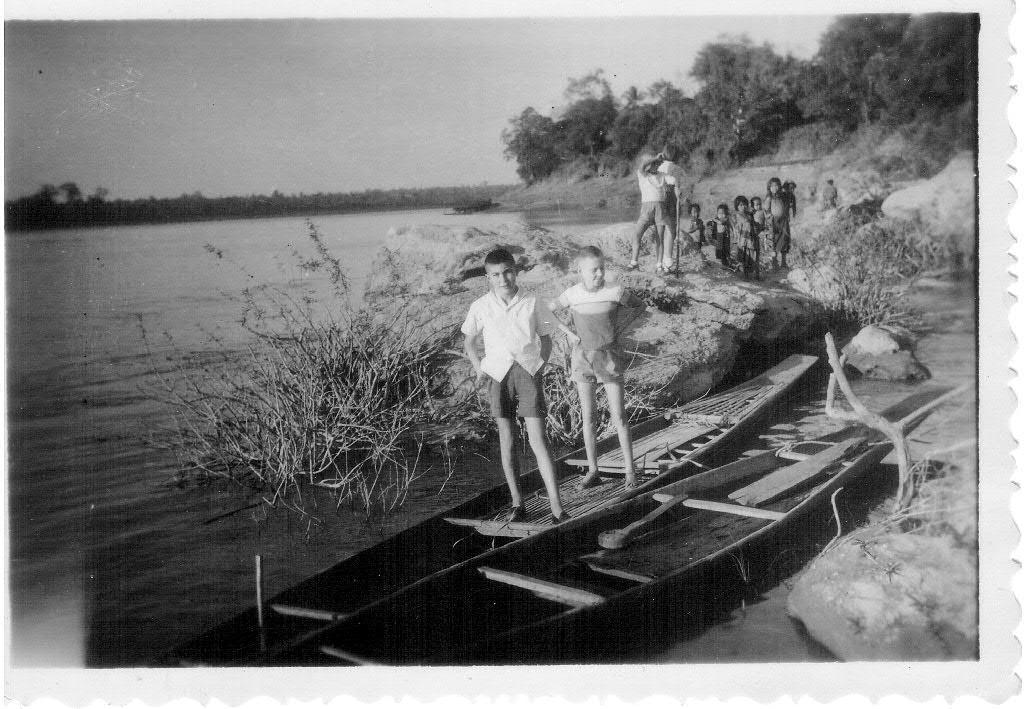How many people are in the boat in the image? There are two people standing in a boat in the image. What can be seen in the background of the image? Trees are visible in the image. What is the primary element surrounding the boat? There is water in the image. What is visible above the boat in the image? The sky is visible in the image. How many baskets are being used by the people in the boat? There is no mention of baskets in the image; the people are standing in a boat without any visible baskets. 